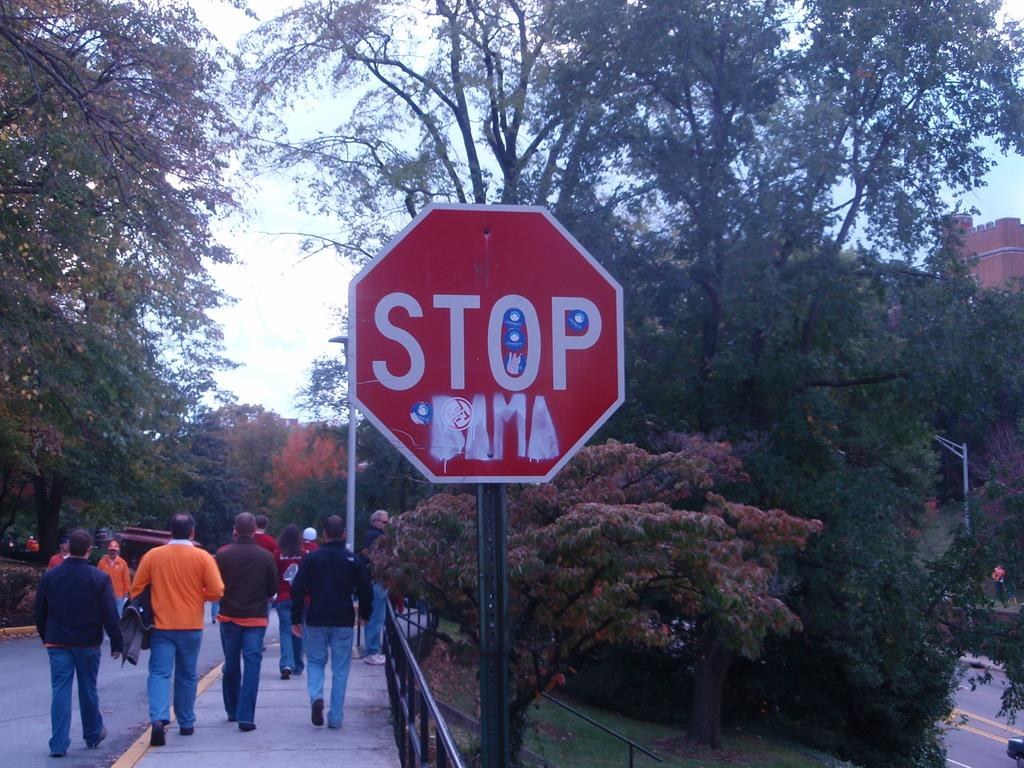Provide a one-sentence caption for the provided image. The red stop sign shown has been grafittied on. 